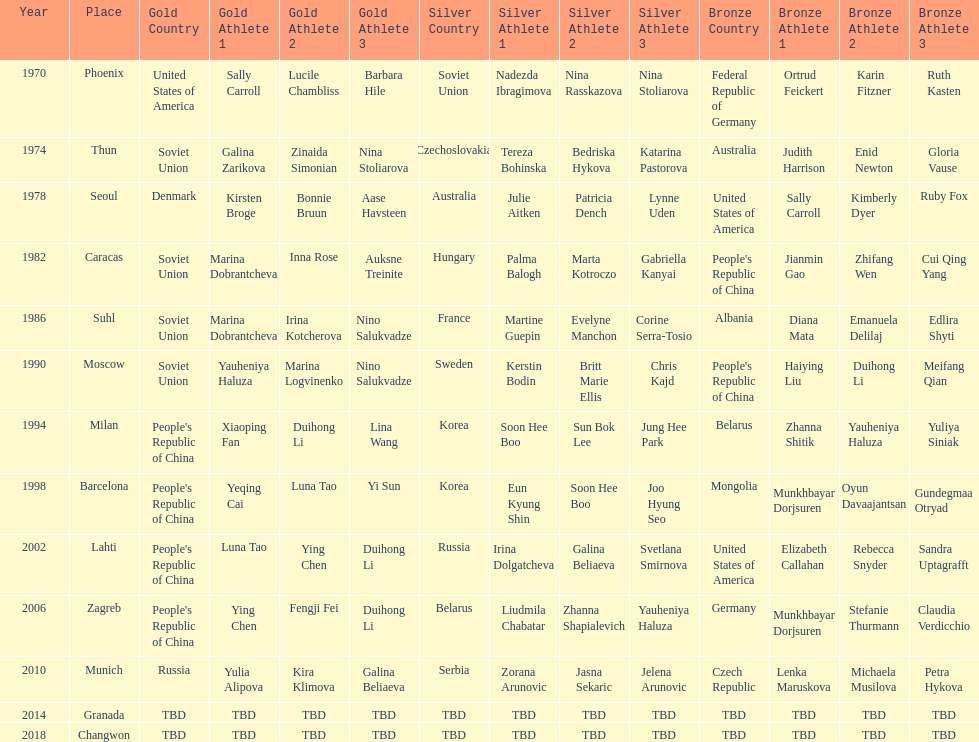Name one of the top three women to earn gold at the 1970 world championship held in phoenix, az Sally Carroll. 